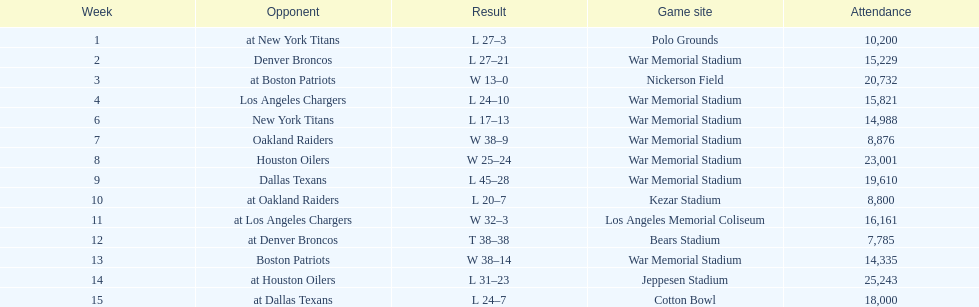On which date was the attendance at its peak? December 11, 1960. 